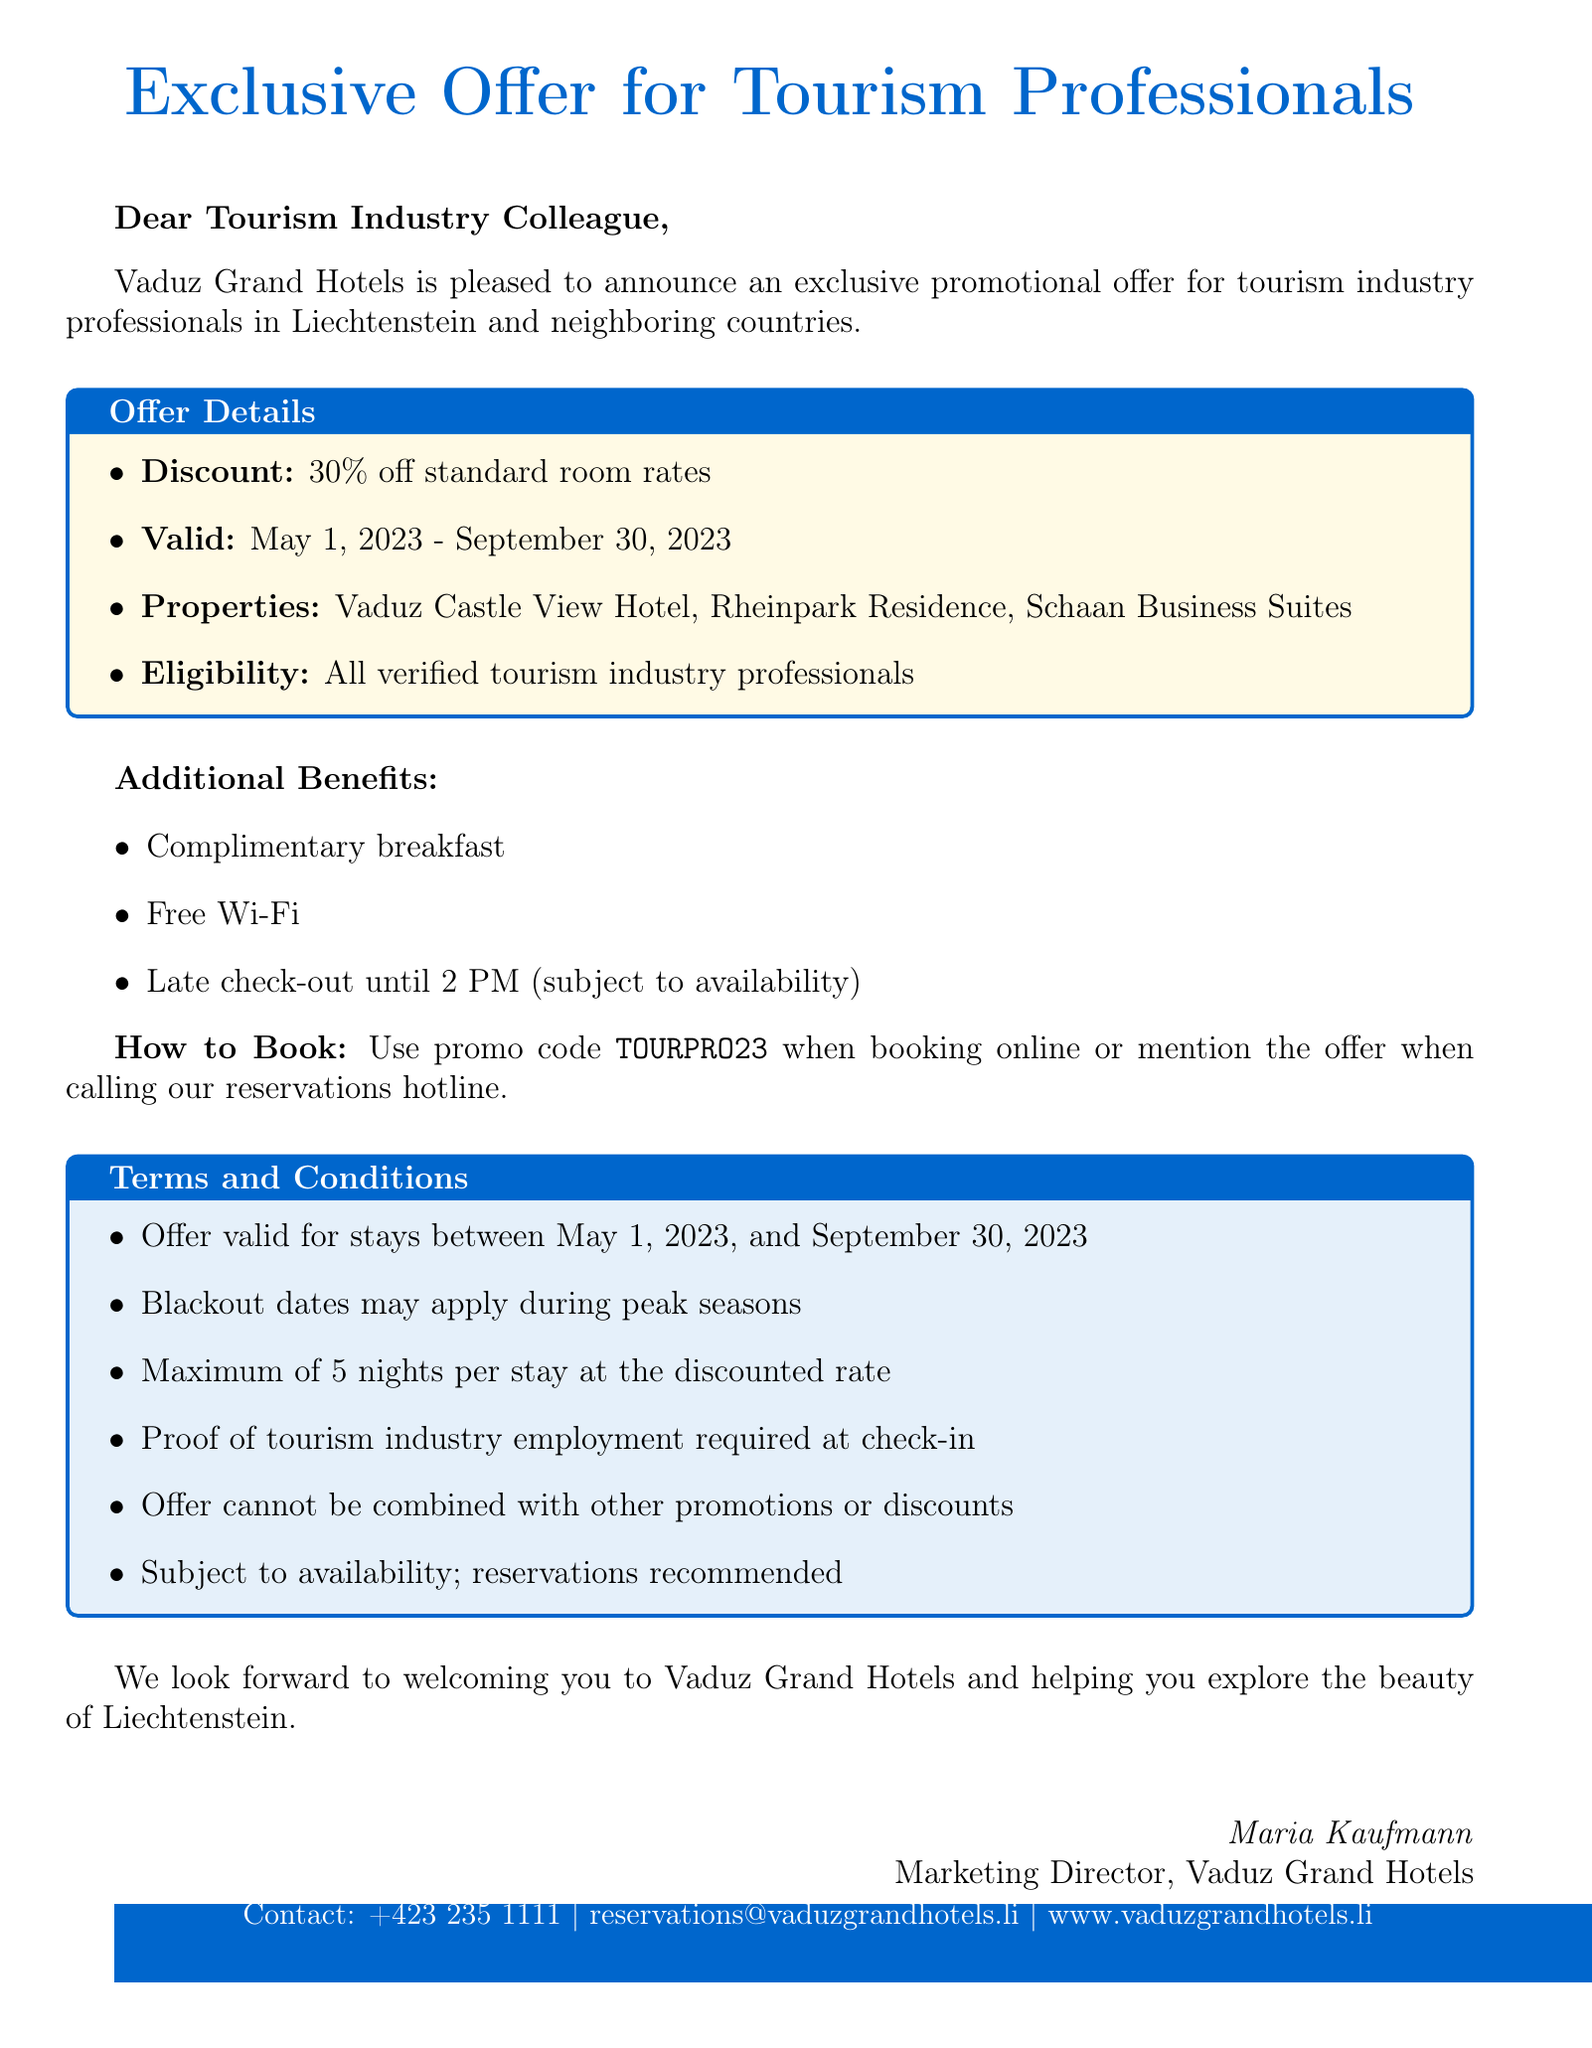What is the discount percentage? The discount percentage is clearly stated in the offer summary section of the document.
Answer: 30% off standard room rates What is the validity period of the offer? The validity period for the promotional offer is specified in the discount details section of the document.
Answer: May 1, 2023 - September 30, 2023 Who is eligible for the offer? Eligibility requirements are outlined in the eligibility section of the document.
Answer: All verified tourism industry professionals What is the maximum length of stay at the discounted rate? The terms concerning length of stay are included in the terms and conditions section.
Answer: 5 nights What must be provided at check-in to avail the offer? The requirements for check-in are clearly specified in the terms and conditions section.
Answer: Proof of tourism industry employment What are the additional benefits included with the offer? The additional benefits section lists the perks that come with the promotional offer.
Answer: Complimentary breakfast, Free Wi-Fi, Late check-out until 2 PM What should be mentioned when booking by phone? The booking instructions specify what needs to be mentioned when calling to book.
Answer: Mention the offer Which hotel properties are part of the Vaduz Grand Hotels chain? The properties under the hotel chain are listed in the hotel chain information section.
Answer: Vaduz Castle View Hotel, Rheinpark Residence, Schaan Business Suites What is the contact email for reservations? The contact information section provides methods to contact the hotel for reservations.
Answer: reservations@vaduzgrandhotels.li 